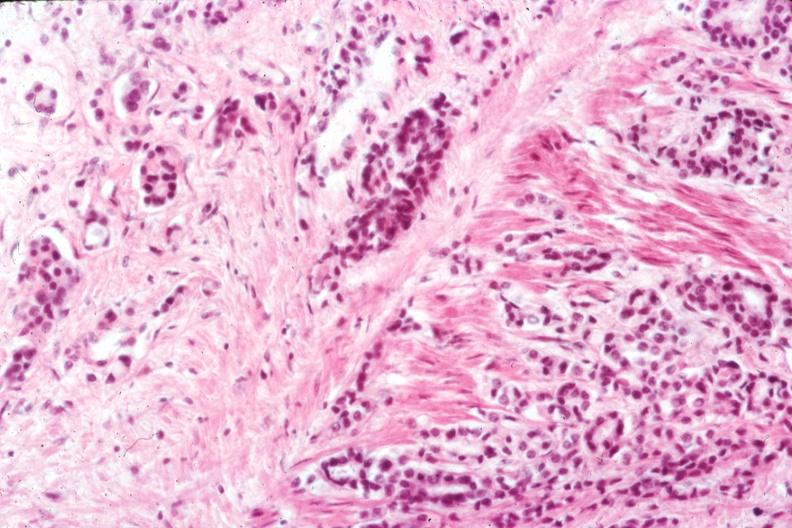does this image show infiltrating adenocarcinoma through smooth muscle typical for this lesion?
Answer the question using a single word or phrase. Yes 